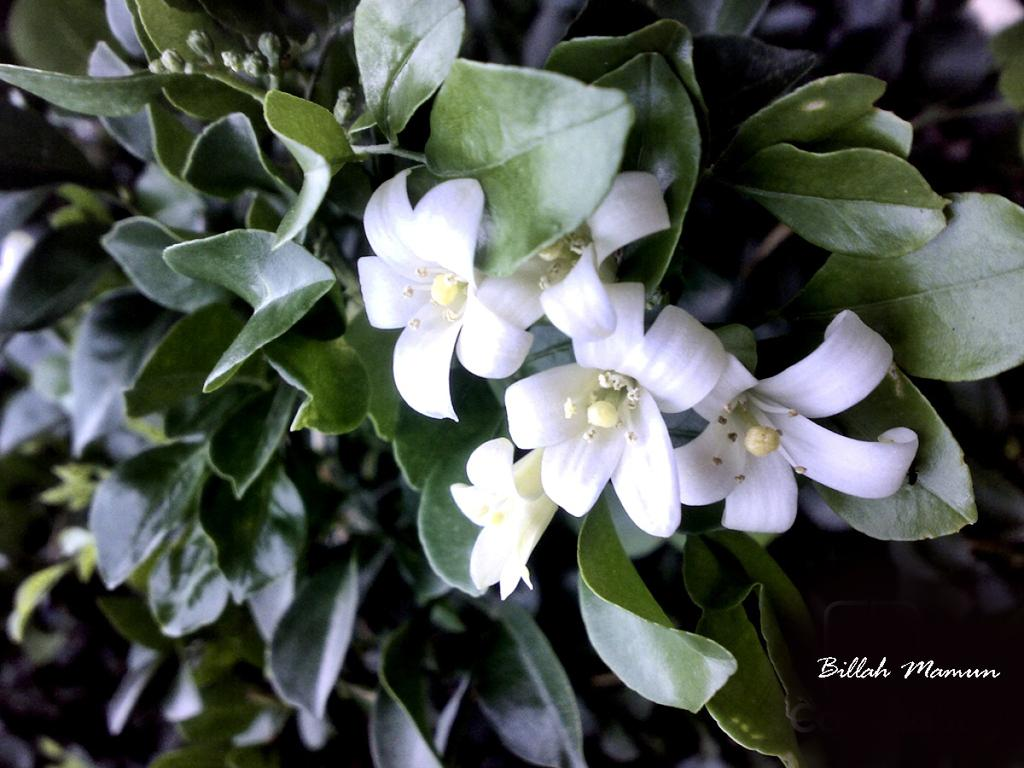What type of living organisms can be seen in the image? Plants can be seen in the image. What color are the flowers on the plants? The flowers on the plants are white. What type of coach is visible in the image? There is no coach present in the image; it features plants with white flowers. What channel is being broadcasted in the image? There is no television or channel present in the image; it features plants with white flowers. 